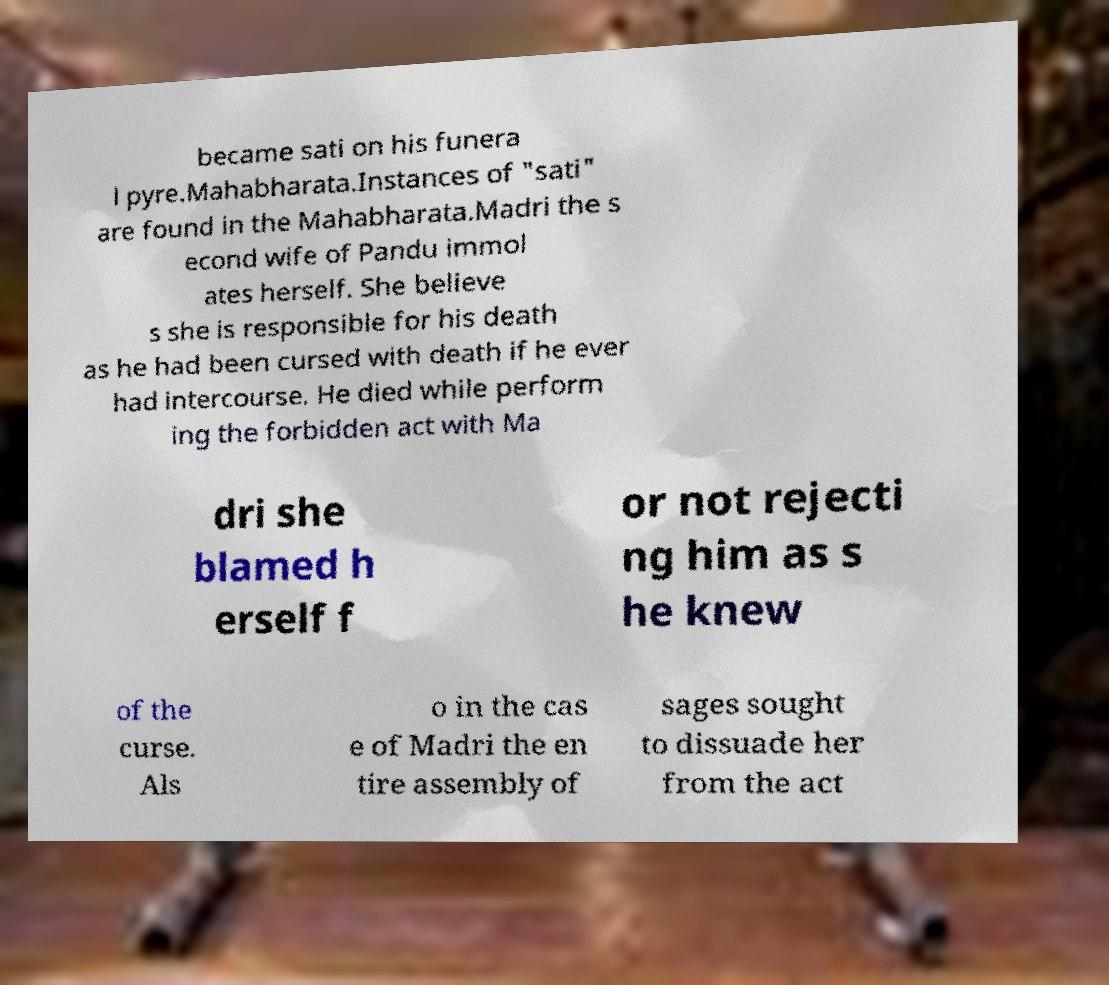Could you extract and type out the text from this image? became sati on his funera l pyre.Mahabharata.Instances of "sati" are found in the Mahabharata.Madri the s econd wife of Pandu immol ates herself. She believe s she is responsible for his death as he had been cursed with death if he ever had intercourse. He died while perform ing the forbidden act with Ma dri she blamed h erself f or not rejecti ng him as s he knew of the curse. Als o in the cas e of Madri the en tire assembly of sages sought to dissuade her from the act 